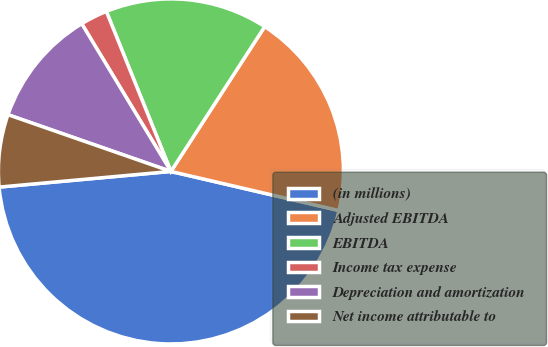Convert chart. <chart><loc_0><loc_0><loc_500><loc_500><pie_chart><fcel>(in millions)<fcel>Adjusted EBITDA<fcel>EBITDA<fcel>Income tax expense<fcel>Depreciation and amortization<fcel>Net income attributable to<nl><fcel>44.91%<fcel>19.49%<fcel>15.25%<fcel>2.54%<fcel>11.02%<fcel>6.78%<nl></chart> 